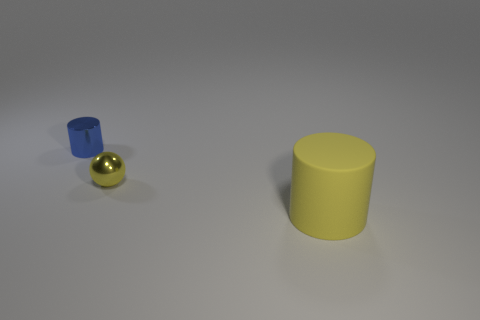What can you infer about the source of lighting in this scene? From the shadows cast by the objects and the highlights on the sphere and the cylinders, it seems that the light source is positioned above and slightly to the left of the scene, as evidenced by the darkest shadow being cast down and to the right, implying a single, diffused light source. 